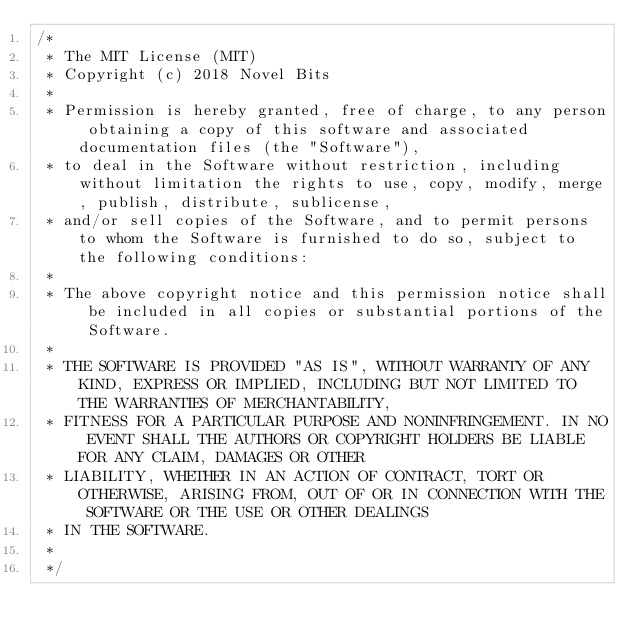<code> <loc_0><loc_0><loc_500><loc_500><_C_>/*
 * The MIT License (MIT)
 * Copyright (c) 2018 Novel Bits
 *
 * Permission is hereby granted, free of charge, to any person obtaining a copy of this software and associated documentation files (the "Software"),
 * to deal in the Software without restriction, including without limitation the rights to use, copy, modify, merge, publish, distribute, sublicense,
 * and/or sell copies of the Software, and to permit persons to whom the Software is furnished to do so, subject to the following conditions:
 *
 * The above copyright notice and this permission notice shall be included in all copies or substantial portions of the Software.
 *
 * THE SOFTWARE IS PROVIDED "AS IS", WITHOUT WARRANTY OF ANY KIND, EXPRESS OR IMPLIED, INCLUDING BUT NOT LIMITED TO THE WARRANTIES OF MERCHANTABILITY,
 * FITNESS FOR A PARTICULAR PURPOSE AND NONINFRINGEMENT. IN NO EVENT SHALL THE AUTHORS OR COPYRIGHT HOLDERS BE LIABLE FOR ANY CLAIM, DAMAGES OR OTHER
 * LIABILITY, WHETHER IN AN ACTION OF CONTRACT, TORT OR OTHERWISE, ARISING FROM, OUT OF OR IN CONNECTION WITH THE SOFTWARE OR THE USE OR OTHER DEALINGS
 * IN THE SOFTWARE.
 *
 */
</code> 